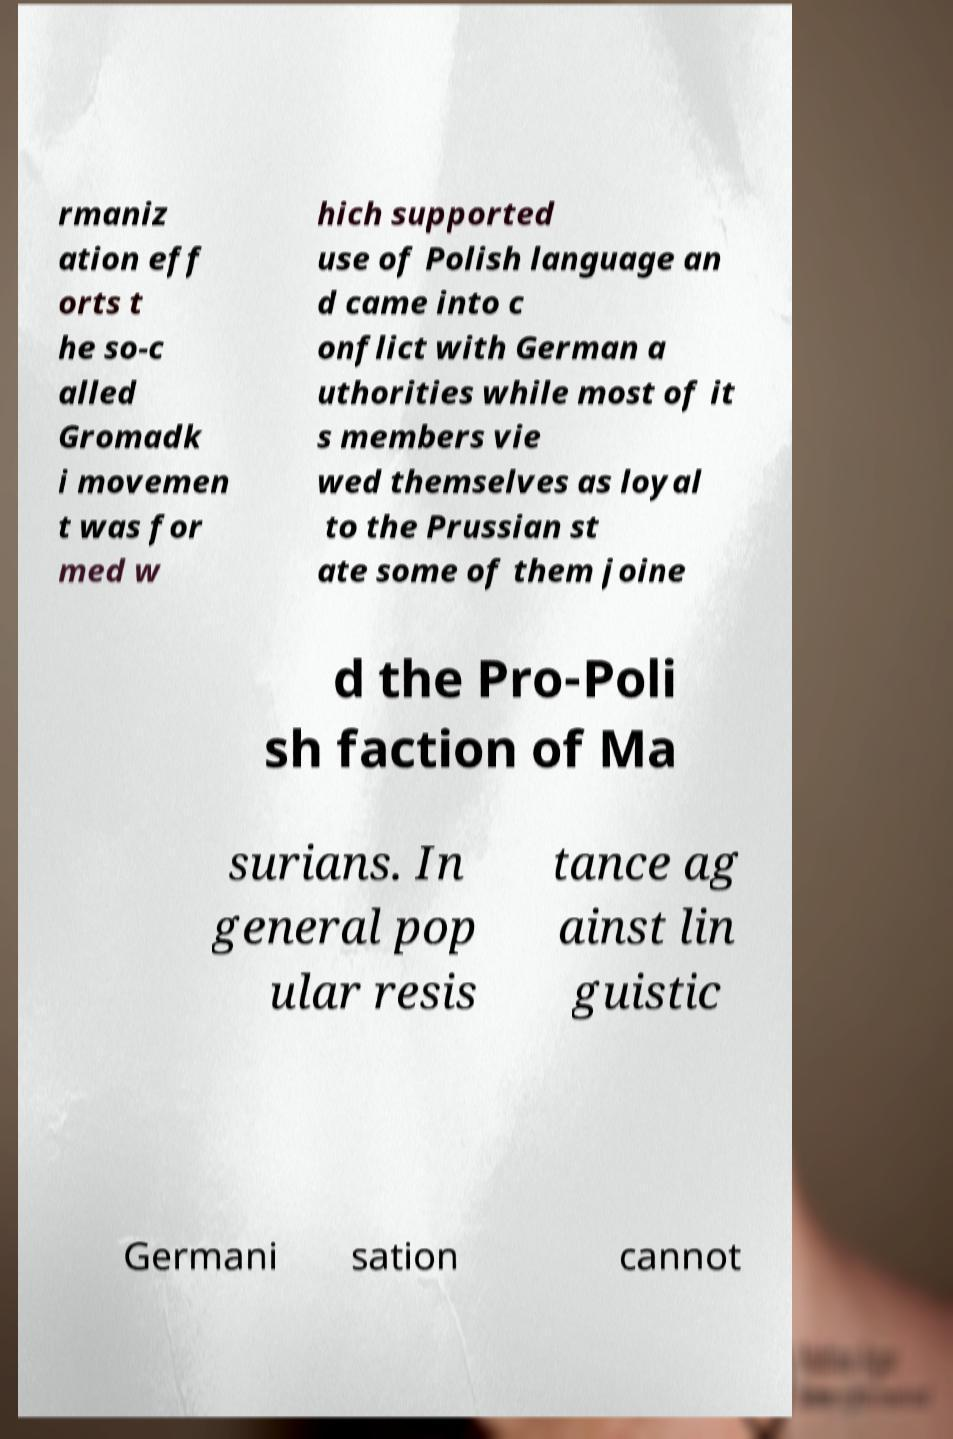Could you assist in decoding the text presented in this image and type it out clearly? rmaniz ation eff orts t he so-c alled Gromadk i movemen t was for med w hich supported use of Polish language an d came into c onflict with German a uthorities while most of it s members vie wed themselves as loyal to the Prussian st ate some of them joine d the Pro-Poli sh faction of Ma surians. In general pop ular resis tance ag ainst lin guistic Germani sation cannot 